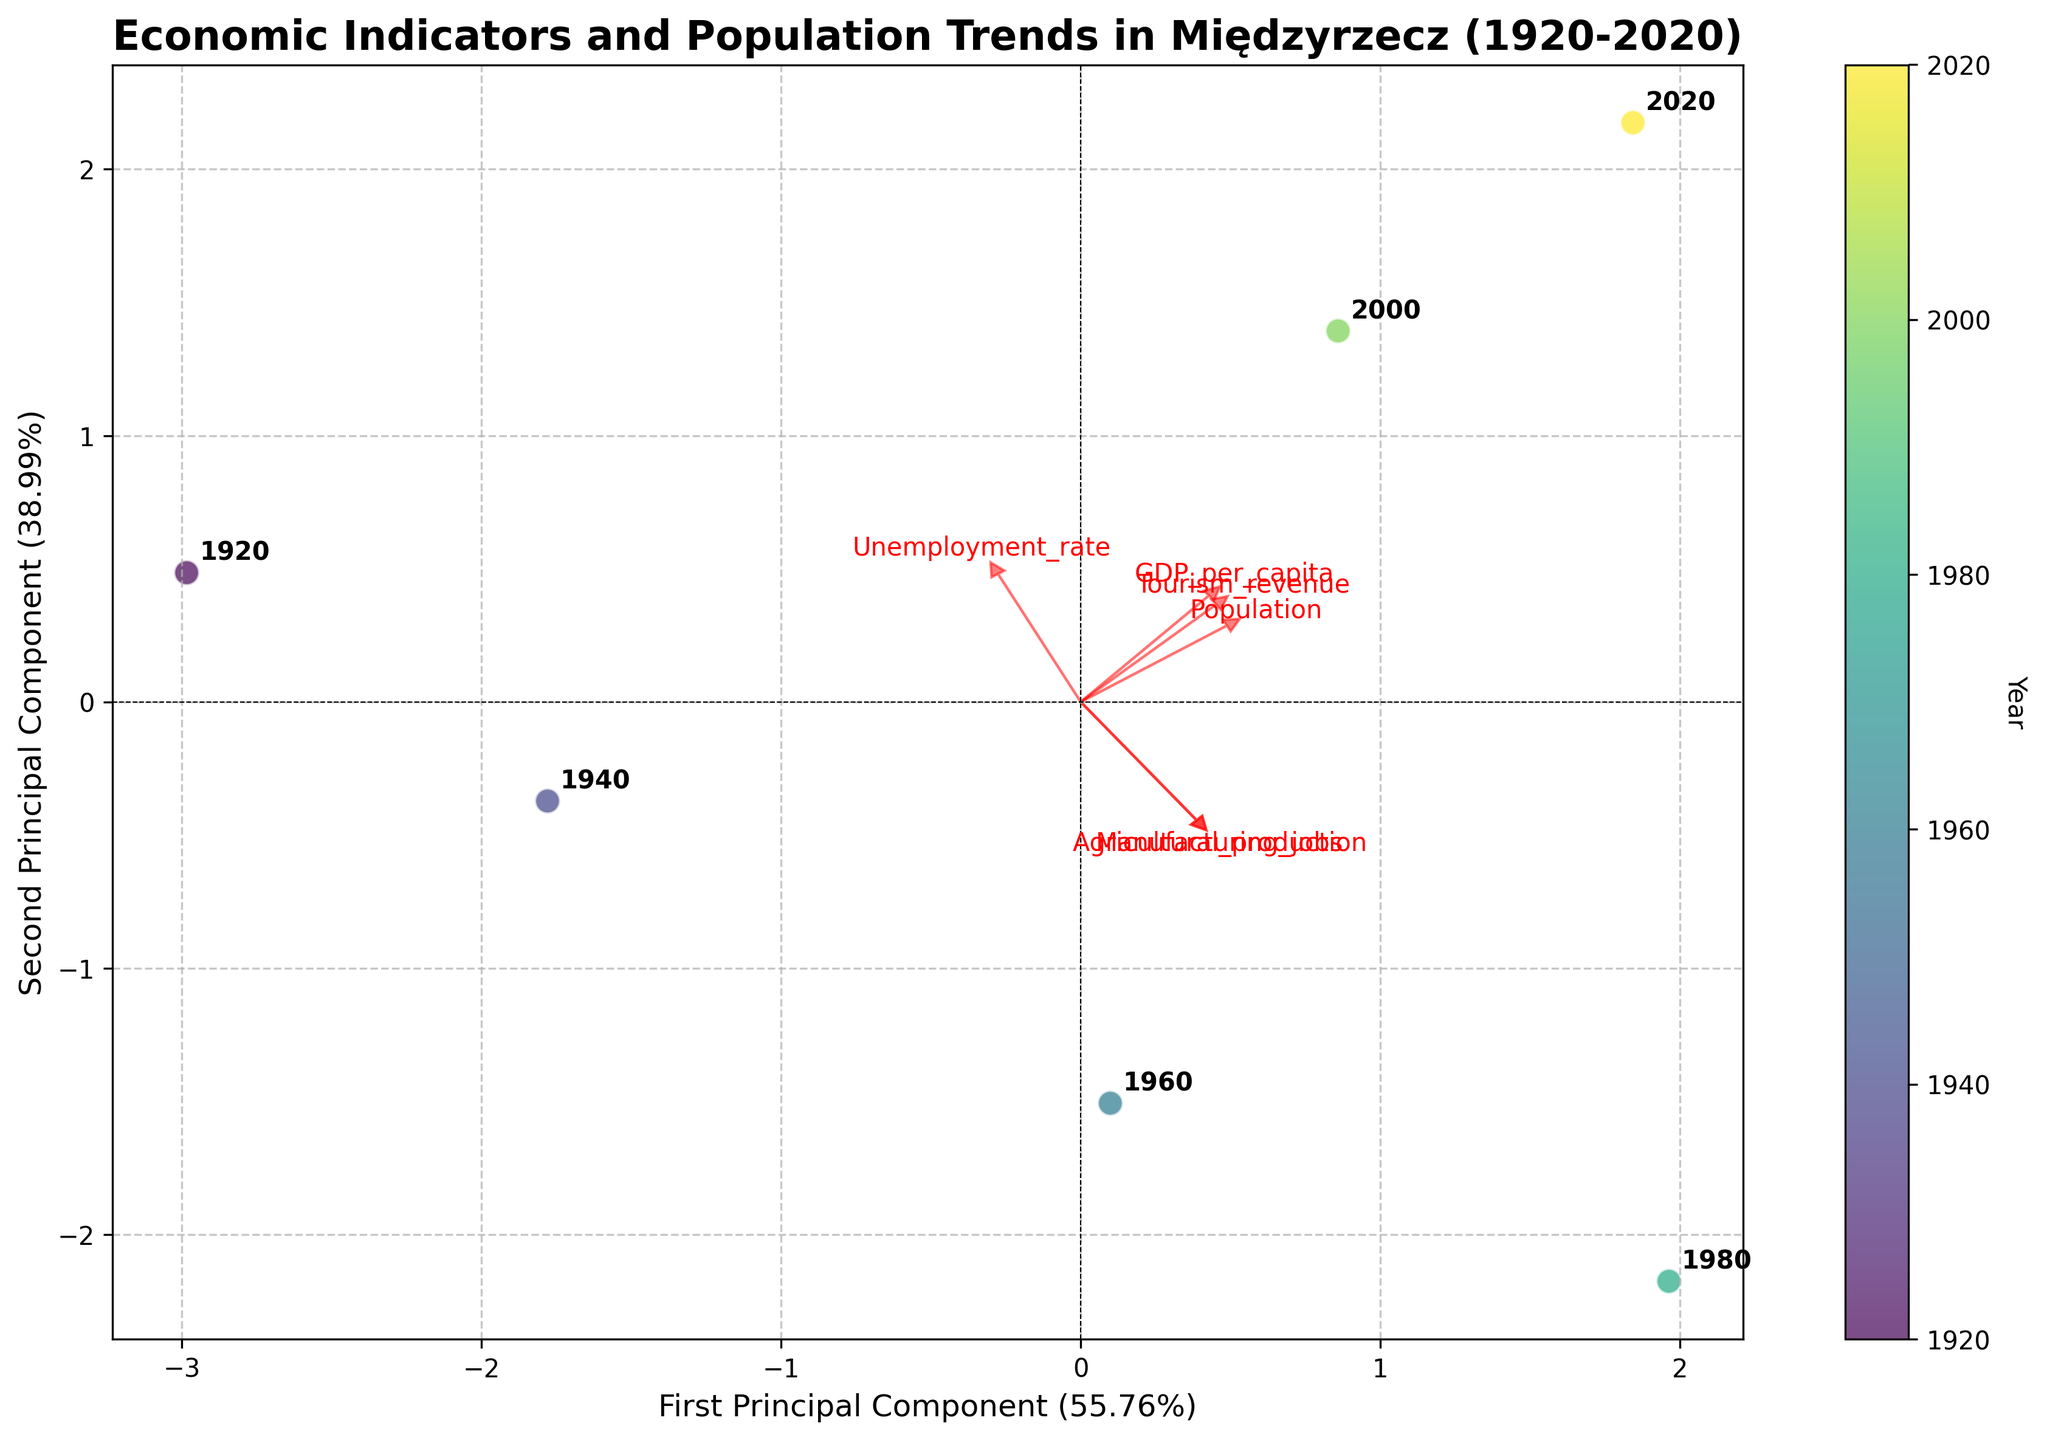How many principal components are plotted in the biplot? The biplot plots two principal components, as indicated by the x-axis and y-axis labels that refer to the first and second principal components.
Answer: 2 What's the title of the biplot? The title of the biplot is displayed at the top of the figure and it reads 'Economic Indicators and Population Trends in Międzyrzecz (1920-2020)'.
Answer: Economic Indicators and Population Trends in Międzyrzecz (1920-2020) What color scale is used to represent the years? The biplot uses a color gradient from the 'viridis' colormap to represent different years. This is indicated by the colorbar, which maps the year values to a gradient scale.
Answer: viridis Which year is represented by the data point furthest to the right on the biplot? The data point furthest to the right can be identified by looking at the position of the points along the first principal component (x-axis) and finding the one with the highest value. The annotated year next to this point is '2020'.
Answer: 2020 How does the direction of 'Tourism_revenue' vector compare to 'Manufacturing_jobs'? The red arrows representing the feature vectors indicate direction and magnitude. By comparing their directions, it is clear that the 'Tourism_revenue' vector points in a different direction compared to the 'Manufacturing_jobs' vector, being more aligned with the horizontal axis.
Answer: Different What's the difference in GDP per capita between 1940 and 2000 based on the biplot? First, identify the position of 1940 and 2000 based on their annotations. The 'GDP_per_capita' is represented by one of the feature vectors. Compare the projections along this vector's direction between the two years on the biplot. The length of the projection difference indicates that the GDP per capita significantly increased over this period.
Answer: Increased significantly Which feature seems to have the largest variability across years based on the biplot? The feature with the longest vector in the biplot has the largest variability, as PCA gives more weight to features with greater variance. 'Tourism_revenue' has the longest vector, indicating that it varies the most.
Answer: Tourism_revenue Are the 'Population' and 'GDP_per_capita' vectors pointing in similar directions? What can be inferred from that? By observing the red arrows, if two vectors point in similar directions, it suggests a positive correlation. The vectors for 'Population' and 'GDP_per_capita' are fairly aligned, indicating a positive relationship between the two features.
Answer: Yes, positive relationship Which year has the smallest influence from 'Unemployment_rate' based on the biplot? 'Unemployment_rate' is one of the feature vectors. The year closest to the origin in the direction opposite this vector will have the smallest influence from 'Unemployment_rate'. Checking the annotations, it seems the year 1980 is closest to this criteria.
Answer: 1980 What can be inferred about the economic trends from 1920 to 2020 in Międzyrzecz based on the biplot? Over the century, there is a general positive trend in indicators like 'GDP_per_capita' and 'Tourism_revenue', as shown by the chronological spread of years along these vectors. The consistent increase in 'Population' indicates economic growth.
Answer: General economic growth 